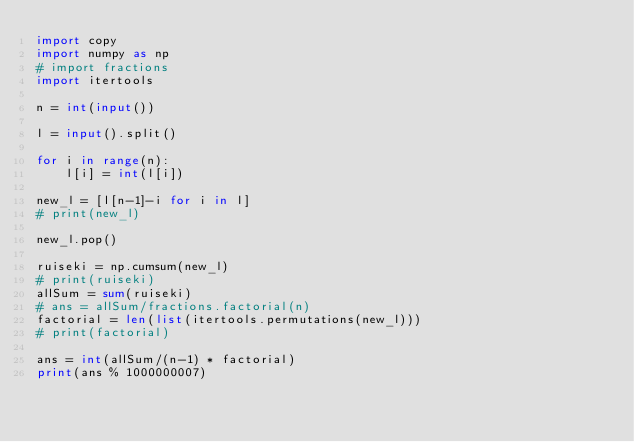<code> <loc_0><loc_0><loc_500><loc_500><_Python_>import copy
import numpy as np
# import fractions
import itertools

n = int(input())

l = input().split()

for i in range(n):
    l[i] = int(l[i])

new_l = [l[n-1]-i for i in l]
# print(new_l)

new_l.pop()

ruiseki = np.cumsum(new_l)
# print(ruiseki)
allSum = sum(ruiseki)
# ans = allSum/fractions.factorial(n)
factorial = len(list(itertools.permutations(new_l)))
# print(factorial)

ans = int(allSum/(n-1) * factorial)
print(ans % 1000000007)
</code> 